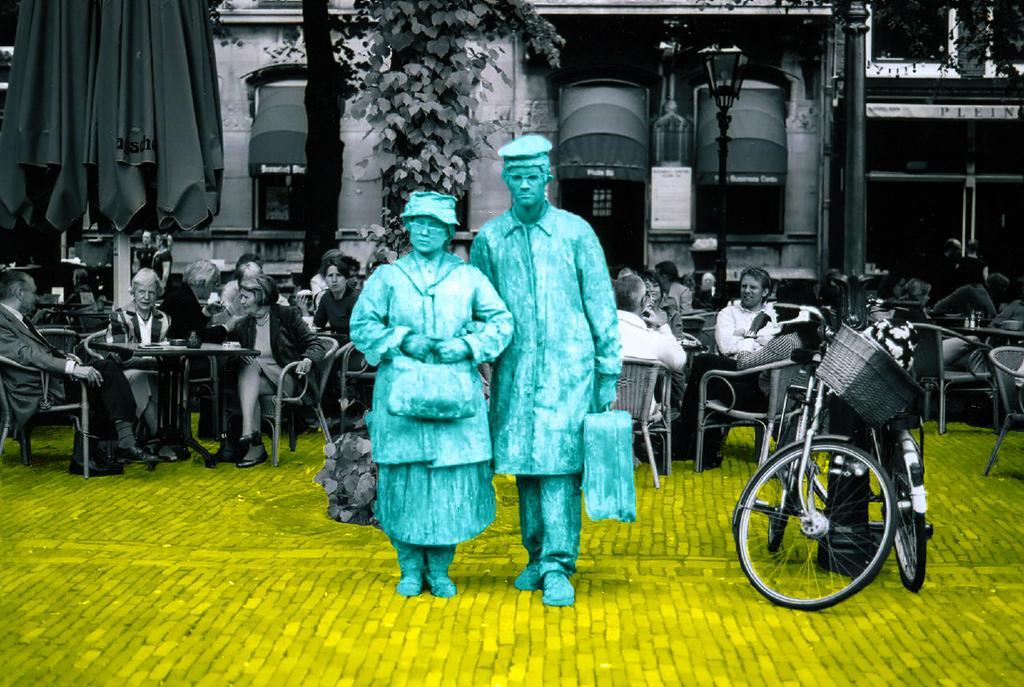Describe this image in one or two sentences. In this image in the center there are two statues, and in the background there are some people who are sitting on chairs. And on the right side there are cycles, in the background there are some windows, wall, plants, pole and lights. And on the left side there is a curtain, at the bottom there is walkway. 